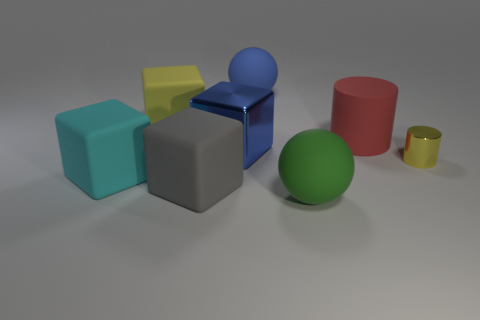Add 1 small cyan shiny blocks. How many objects exist? 9 Subtract all cylinders. How many objects are left? 6 Add 4 large cyan objects. How many large cyan objects exist? 5 Subtract 0 green blocks. How many objects are left? 8 Subtract all large brown shiny cylinders. Subtract all yellow things. How many objects are left? 6 Add 7 big blue balls. How many big blue balls are left? 8 